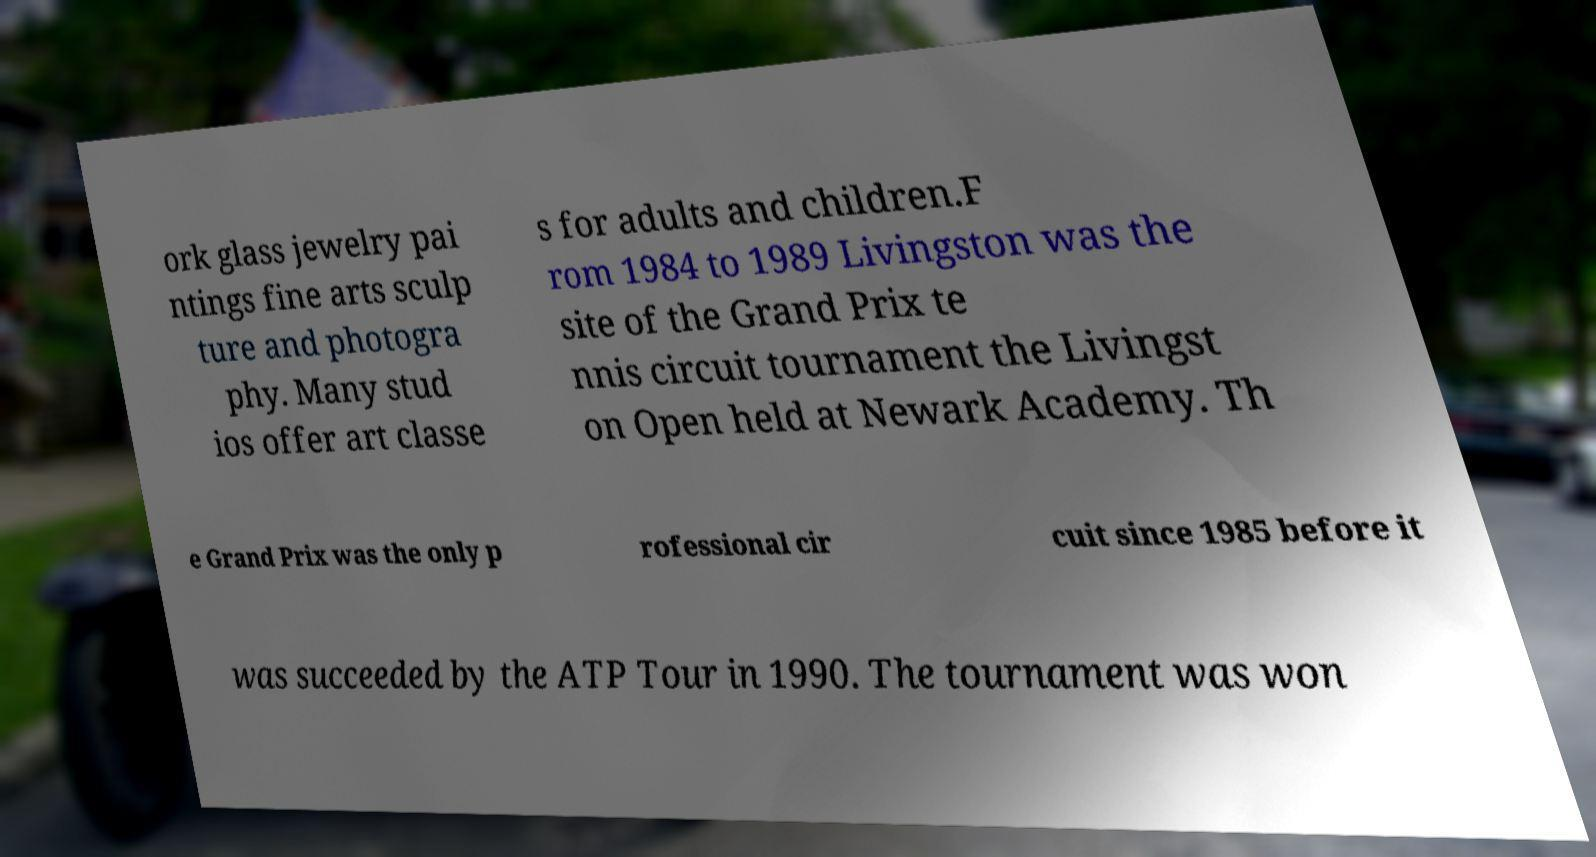What messages or text are displayed in this image? I need them in a readable, typed format. ork glass jewelry pai ntings fine arts sculp ture and photogra phy. Many stud ios offer art classe s for adults and children.F rom 1984 to 1989 Livingston was the site of the Grand Prix te nnis circuit tournament the Livingst on Open held at Newark Academy. Th e Grand Prix was the only p rofessional cir cuit since 1985 before it was succeeded by the ATP Tour in 1990. The tournament was won 